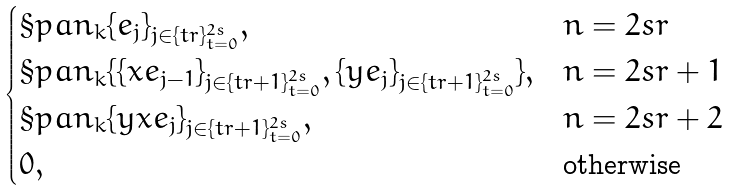<formula> <loc_0><loc_0><loc_500><loc_500>\begin{cases} \S p a n _ { k } \{ e _ { j } \} _ { j \in \{ t r \} _ { t = 0 } ^ { 2 s } } , & n = 2 s r \\ \S p a n _ { k } \{ \{ x e _ { j - 1 } \} _ { j \in \{ t r + 1 \} _ { t = 0 } ^ { 2 s } } , \{ y e _ { j } \} _ { j \in \{ t r + 1 \} _ { t = 0 } ^ { 2 s } } \} , & n = 2 s r + 1 \\ \S p a n _ { k } \{ y x e _ { j } \} _ { j \in \{ t r + 1 \} _ { t = 0 } ^ { 2 s } } , & n = 2 s r + 2 \\ 0 , & \text {otherwise} \end{cases}</formula> 